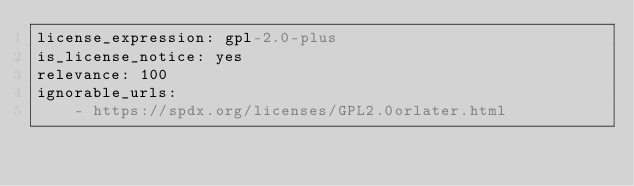Convert code to text. <code><loc_0><loc_0><loc_500><loc_500><_YAML_>license_expression: gpl-2.0-plus
is_license_notice: yes
relevance: 100
ignorable_urls:
    - https://spdx.org/licenses/GPL2.0orlater.html
</code> 